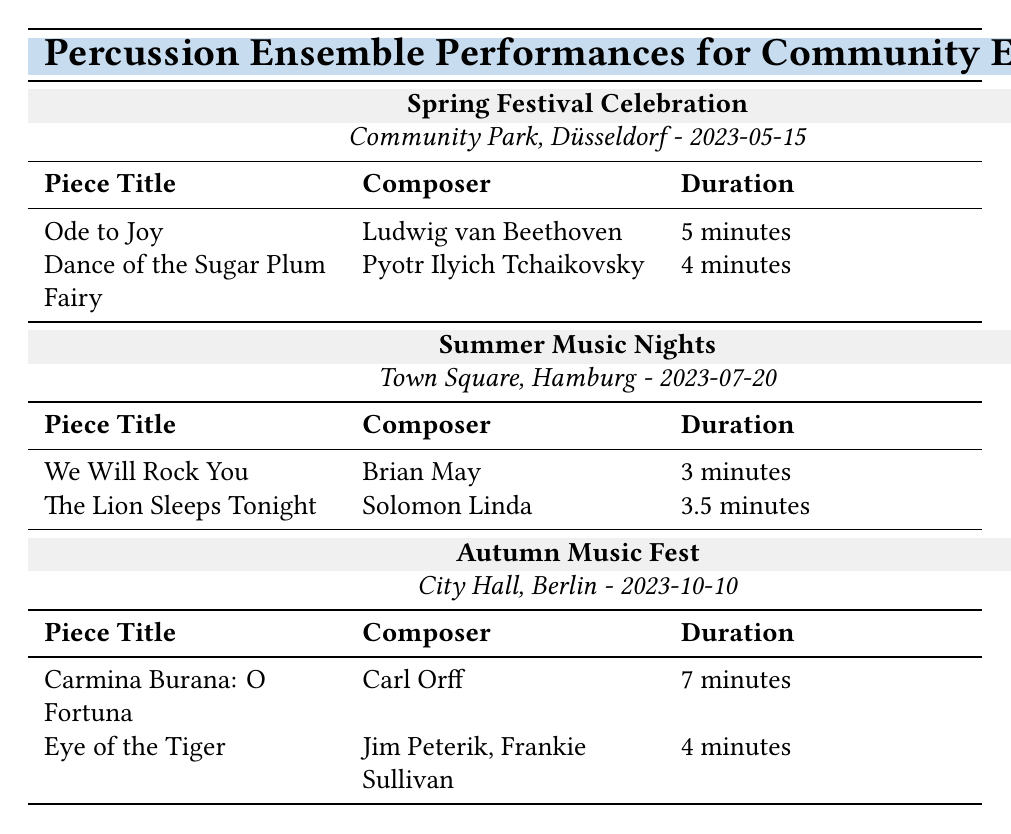What is the location of the Spring Festival Celebration? The table lists the location under the "Spring Festival Celebration" section. It clearly indicates that the event is held at "Community Park, Düsseldorf."
Answer: Community Park, Düsseldorf How long is the performance of "Eye of the Tiger"? Looking at the repertoire for the "Autumn Music Fest," the duration for "Eye of the Tiger" is specified as "4 minutes."
Answer: 4 minutes Which composer arranged "Ode to Joy" for percussion ensemble? The piece title "Ode to Joy" is associated with the composer Ludwig van Beethoven, and the arrangement is credited to "John Doe."
Answer: John Doe Is "We Will Rock You" performed at the Autumn Music Fest? The repertoire for the "Autumn Music Fest" does not list "We Will Rock You," which is actually part of the "Summer Music Nights." Therefore, the answer is "No."
Answer: No What is the total duration of pieces performed at the Summer Music Nights? The durations for the two pieces are "3 minutes" for "We Will Rock You" and "3.5 minutes" for "The Lion Sleeps Tonight." Adding these gives a total of 3 + 3.5 = 6.5 minutes.
Answer: 6.5 minutes Which event features the longest piece duration in the repertoire? By comparing the durations of all performances listed, "Carmina Burana: O Fortuna" at "7 minutes" is the longest duration, found under the "Autumn Music Fest."
Answer: Autumn Music Fest How many pieces are performed at the Spring Festival Celebration? The Spring Festival Celebration has two pieces listed: "Ode to Joy" and "Dance of the Sugar Plum Fairy." Hence, there are two pieces performed at this event.
Answer: 2 What is the average duration of the pieces performed at the events? The durations are 5, 4, 3, 3.5, 7, and 4 minutes (total 6 pieces). First, we sum these: 5 + 4 + 3 + 3.5 + 7 + 4 = 27. Then, we divide by 6 (the number of pieces) to find the average: 27 / 6 = 4.5 minutes.
Answer: 4.5 minutes 